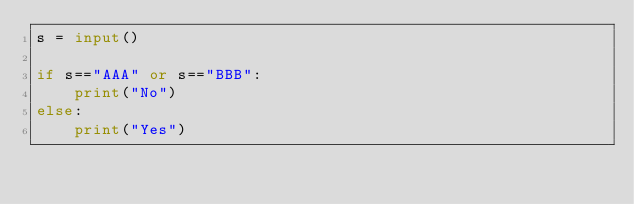Convert code to text. <code><loc_0><loc_0><loc_500><loc_500><_Python_>s = input()

if s=="AAA" or s=="BBB":
    print("No")
else:
    print("Yes")</code> 